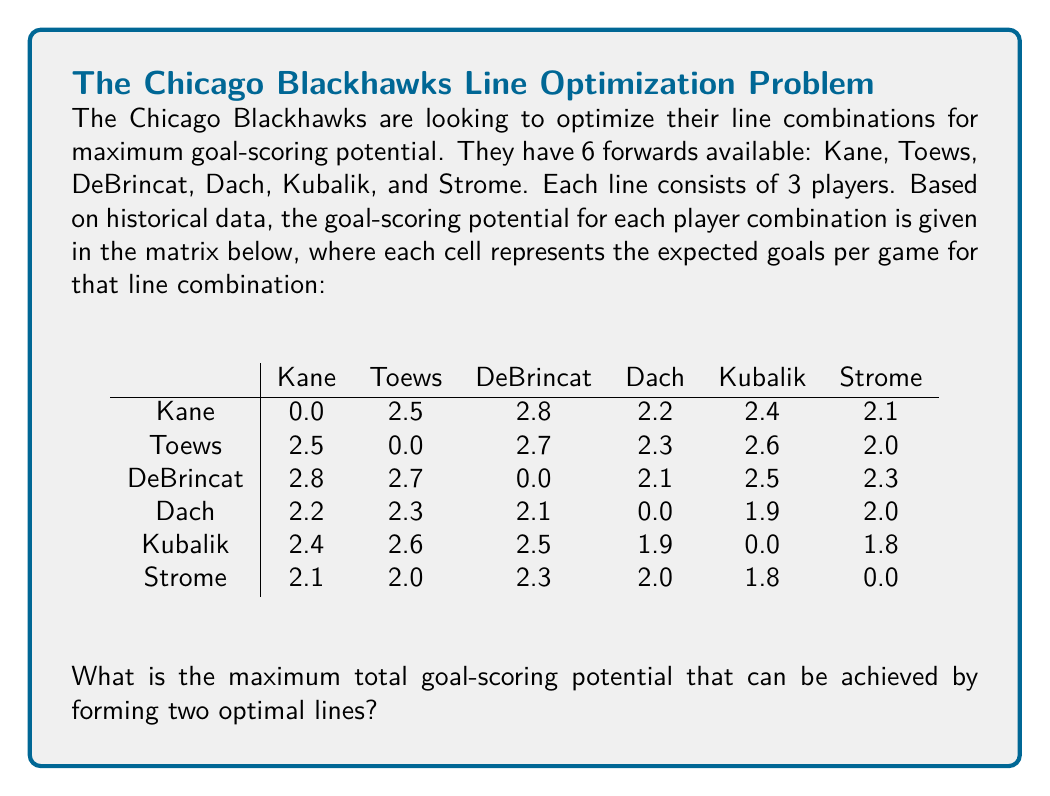Could you help me with this problem? To solve this problem, we need to find the two best line combinations that maximize the total goal-scoring potential. Let's approach this step-by-step:

1) First, we need to calculate the goal-scoring potential for each possible line combination. A line consists of 3 players, so we need to sum the values for each pair in that line.

2) For example, the line of Kane-Toews-DeBrincat would have a potential of:
   $2.5 + 2.8 + 2.7 = 8.0$ goals per game

3) We need to calculate this for all possible combinations of 3 players out of 6. There are $\binom{6}{3} = 20$ such combinations.

4) After calculating all combinations, we find the top scoring lines are:
   - Kane-Toews-DeBrincat: 8.0 goals/game
   - Kane-DeBrincat-Kubalik: 7.7 goals/game
   - Toews-DeBrincat-Kubalik: 7.8 goals/game
   - Kane-Toews-Kubalik: 7.5 goals/game

5) However, we can't use the same player in both lines. The optimal solution is to use the first and fourth highest scoring lines:
   - Line 1: Kane-Toews-DeBrincat (8.0 goals/game)
   - Line 2: Dach-Kubalik-Strome (5.7 goals/game)

6) The total goal-scoring potential is the sum of these two lines:
   $8.0 + 5.7 = 13.7$ goals per game

Therefore, the maximum total goal-scoring potential that can be achieved by forming two optimal lines is 13.7 goals per game.
Answer: 13.7 goals/game 